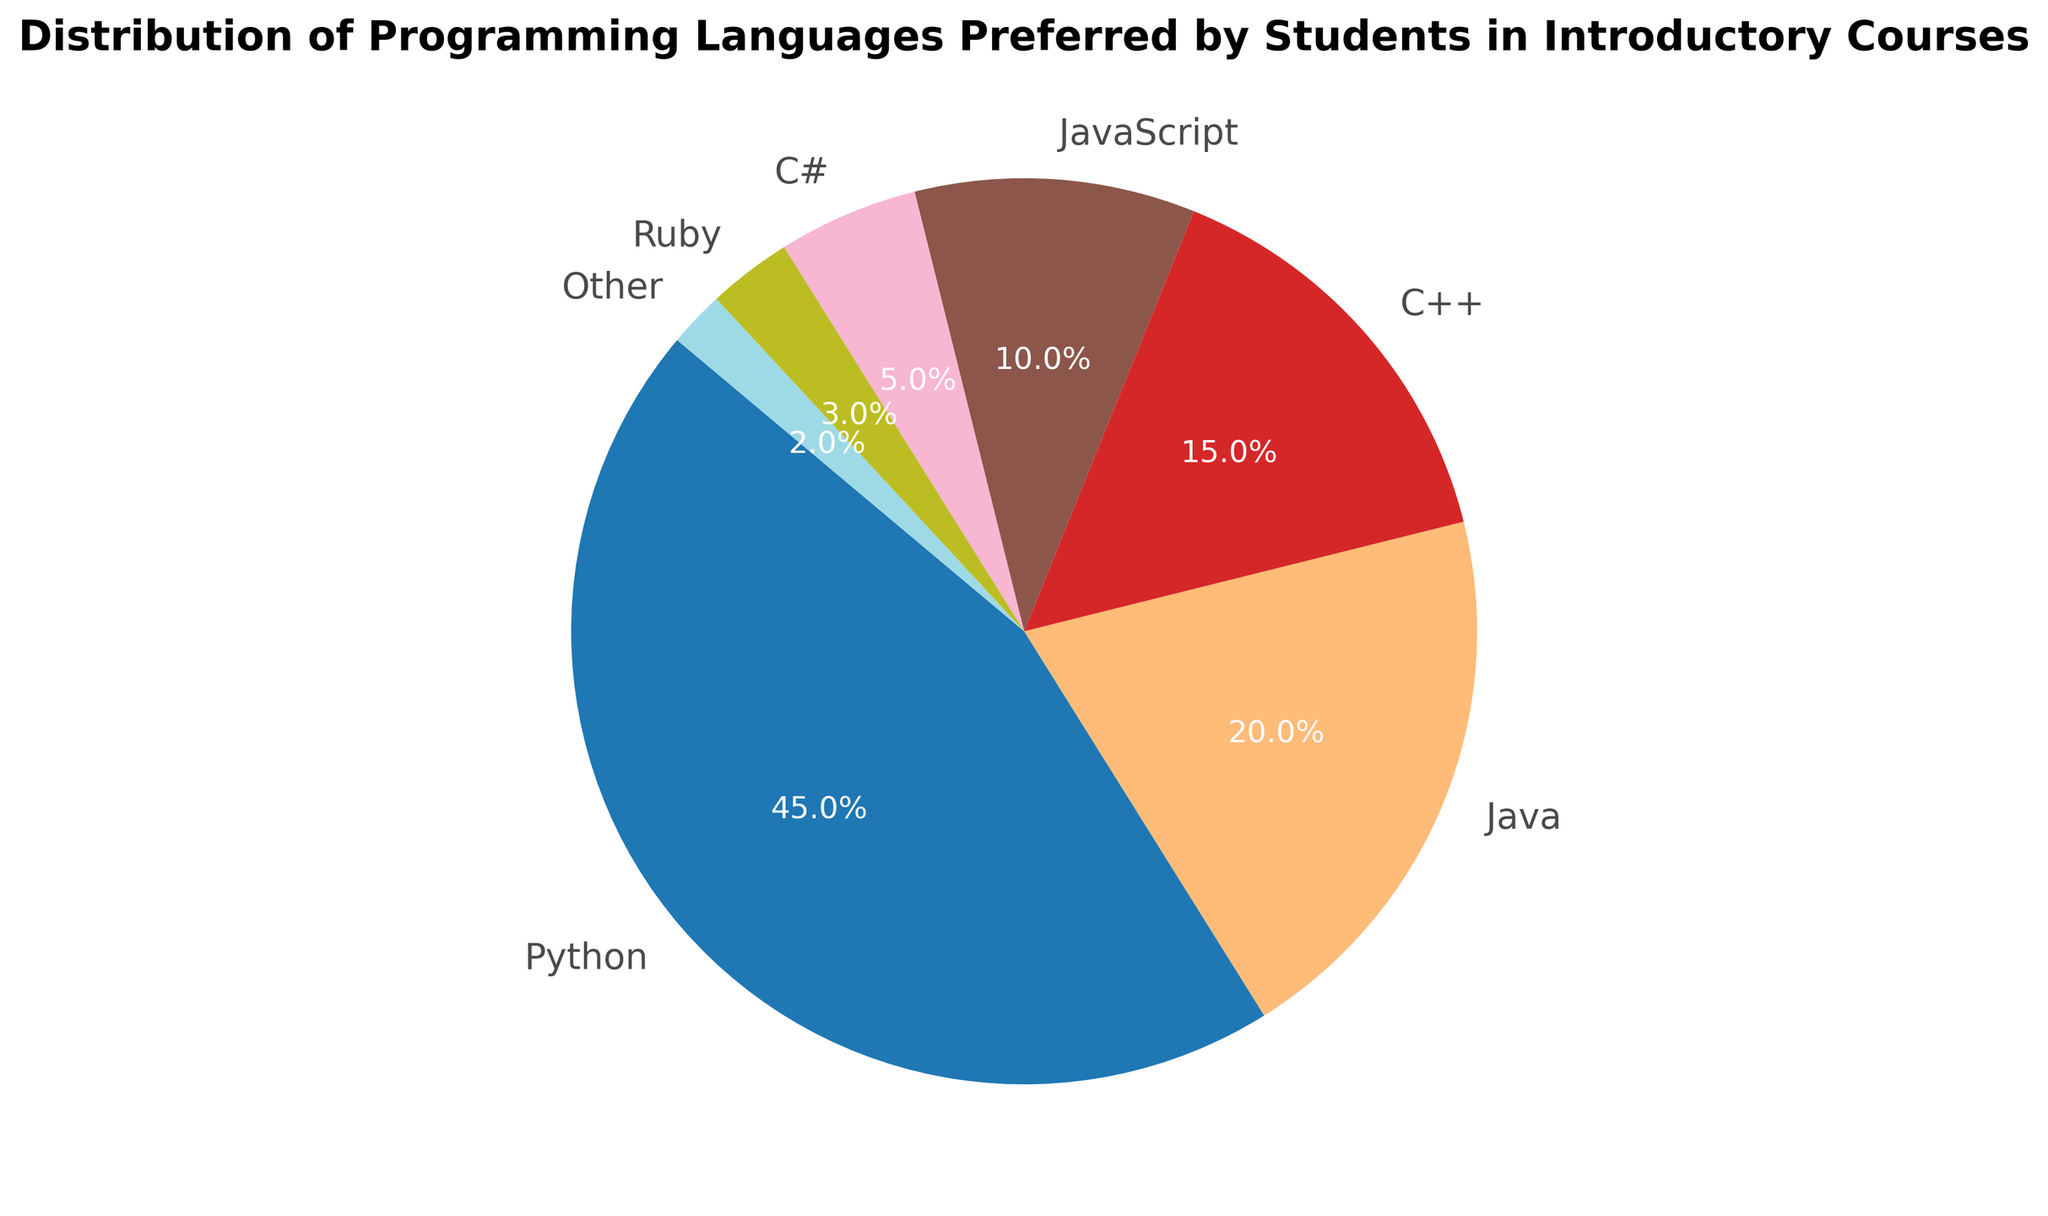What percentage of students prefer Python compared to Java? The percentage of students preferring Python is 45%, while those preferring Java is 20%. The question is about comparing these two percentages directly.
Answer: Python: 45%, Java: 20% Which languages collectively make up more than half of the preferences? Summing the percentages of Python (45%), Java (20%), C++ (15%), and JavaScript (10%) gives 90%, which is more than half of the preferences. The individual percentages indicate that Python alone is not enough, but multiple languages together surpass 50%.
Answer: Python, Java, C++, and JavaScript What is the percentage difference between students preferring JavaScript and Ruby? The percentage of students preferring JavaScript is 10%, whereas for Ruby it is 3%. The difference is calculated by subtracting these values: 10% - 3% = 7%.
Answer: 7% If you combine the preferences for C# and Other, what percentage do you get? Preferences for C# are 5% and for Other is 2%. Adding these together: 5% + 2% = 7%.
Answer: 7% Which programming language is preferred by the smallest percentage of students? The smallest percentage is shown for the category "Other," which holds 2%. This value is compared to the percentages of all other languages.
Answer: Other How many times more students prefer Python over those who prefer Ruby? The percentage of students preferring Python is 45%, and for Ruby, it is 3%. Dividing these values gives: 45% / 3% = 15 times.
Answer: 15 times What color represents Java on the pie chart? The color scheme used is 'tab20', assigning each language a specific color. Based on the order, Java is represented by the second color in the sequence. Visually inspecting the second wedge in the pie chart confirms its color.
Answer: Color of second wedge in 'tab20' scheme What's the combined percentage for Java and C++? Adding the percentages of Java (20%) and C++ (15%): 20% + 15% = 35%.
Answer: 35% What language comes immediately after JavaScript in terms of preference percentage? JavaScript accounts for 10% of the preferences. The next smaller percentage is C#, which has 5%.
Answer: C# What is the median percentage preference among all listed languages? Listing the preferences: 45%, 20%, 15%, 10%, 5%, 3%, 2%. Arranging in ascending order: 2%, 3%, 5%, 10%, 15%, 20%, 45%. The middle value (median) is 10%.
Answer: 10% 